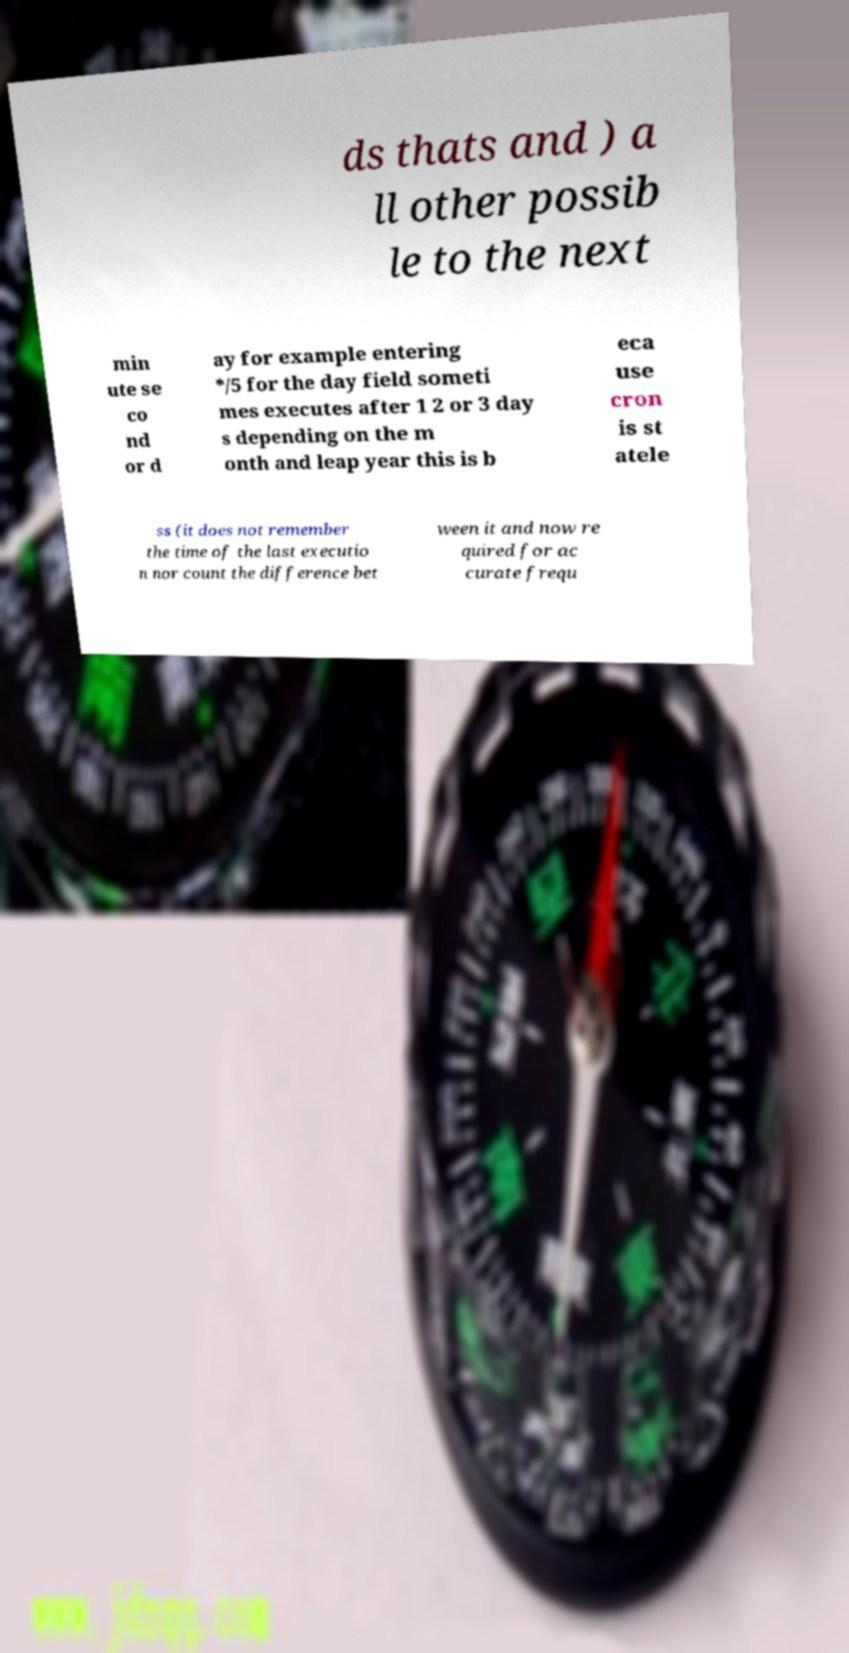Can you accurately transcribe the text from the provided image for me? ds thats and ) a ll other possib le to the next min ute se co nd or d ay for example entering */5 for the day field someti mes executes after 1 2 or 3 day s depending on the m onth and leap year this is b eca use cron is st atele ss (it does not remember the time of the last executio n nor count the difference bet ween it and now re quired for ac curate frequ 